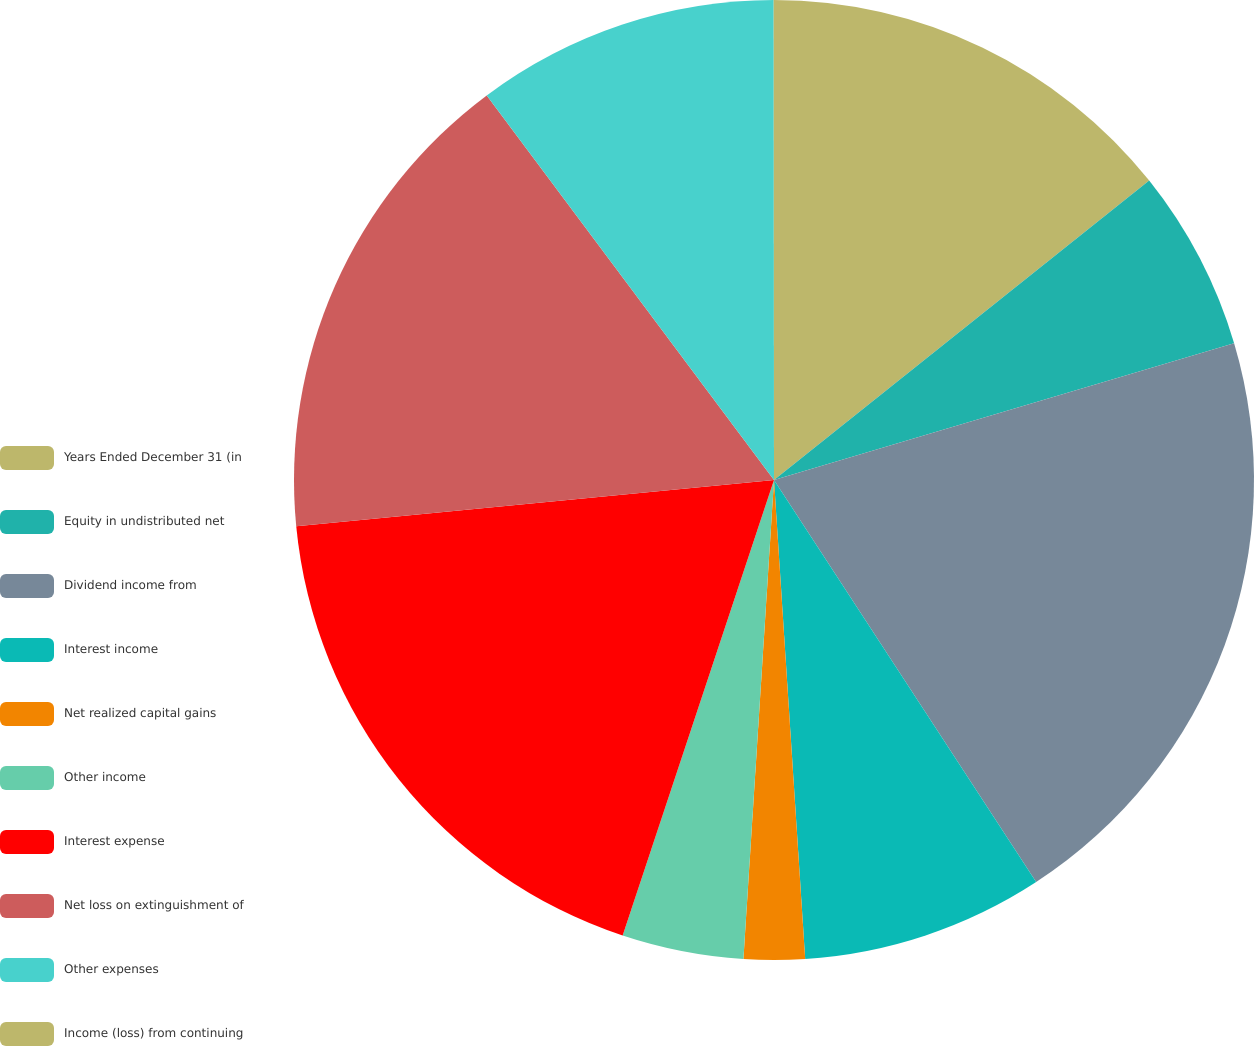<chart> <loc_0><loc_0><loc_500><loc_500><pie_chart><fcel>Years Ended December 31 (in<fcel>Equity in undistributed net<fcel>Dividend income from<fcel>Interest income<fcel>Net realized capital gains<fcel>Other income<fcel>Interest expense<fcel>Net loss on extinguishment of<fcel>Other expenses<fcel>Income (loss) from continuing<nl><fcel>14.28%<fcel>6.12%<fcel>20.4%<fcel>8.16%<fcel>2.05%<fcel>4.09%<fcel>18.36%<fcel>16.32%<fcel>10.2%<fcel>0.01%<nl></chart> 